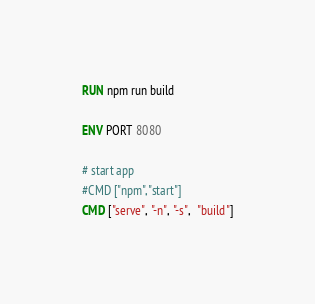<code> <loc_0><loc_0><loc_500><loc_500><_Dockerfile_>
RUN npm run build 

ENV PORT 8080

# start app
#CMD ["npm", "start"]
CMD ["serve", "-n", "-s",  "build"]
</code> 